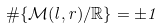<formula> <loc_0><loc_0><loc_500><loc_500>\# \{ \mathcal { M } ( l , r ) / \mathbb { R } \} = \pm 1</formula> 